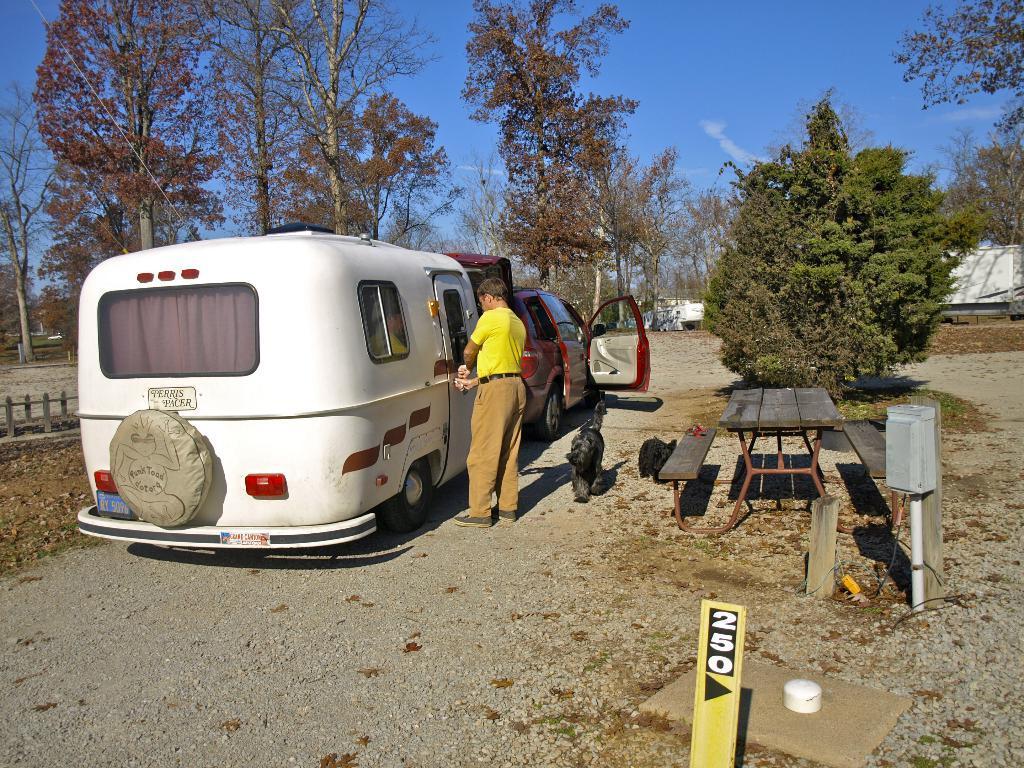Can you describe this image briefly? In this image I can see a man is standing next to white vehicle. I can also see one more vehicle, number of trees and clear view of sky. 